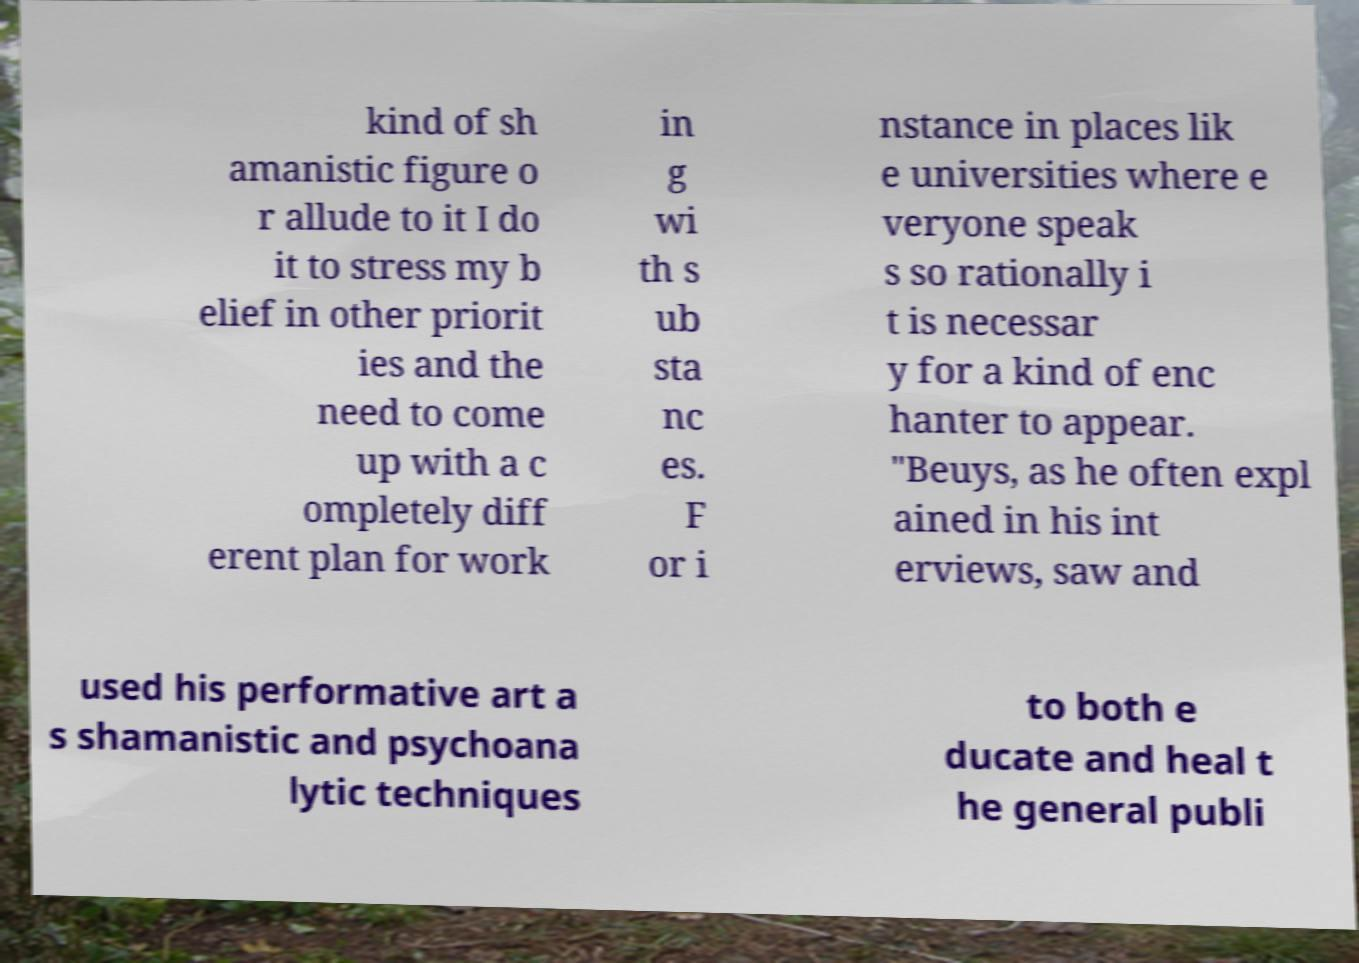Can you accurately transcribe the text from the provided image for me? kind of sh amanistic figure o r allude to it I do it to stress my b elief in other priorit ies and the need to come up with a c ompletely diff erent plan for work in g wi th s ub sta nc es. F or i nstance in places lik e universities where e veryone speak s so rationally i t is necessar y for a kind of enc hanter to appear. "Beuys, as he often expl ained in his int erviews, saw and used his performative art a s shamanistic and psychoana lytic techniques to both e ducate and heal t he general publi 